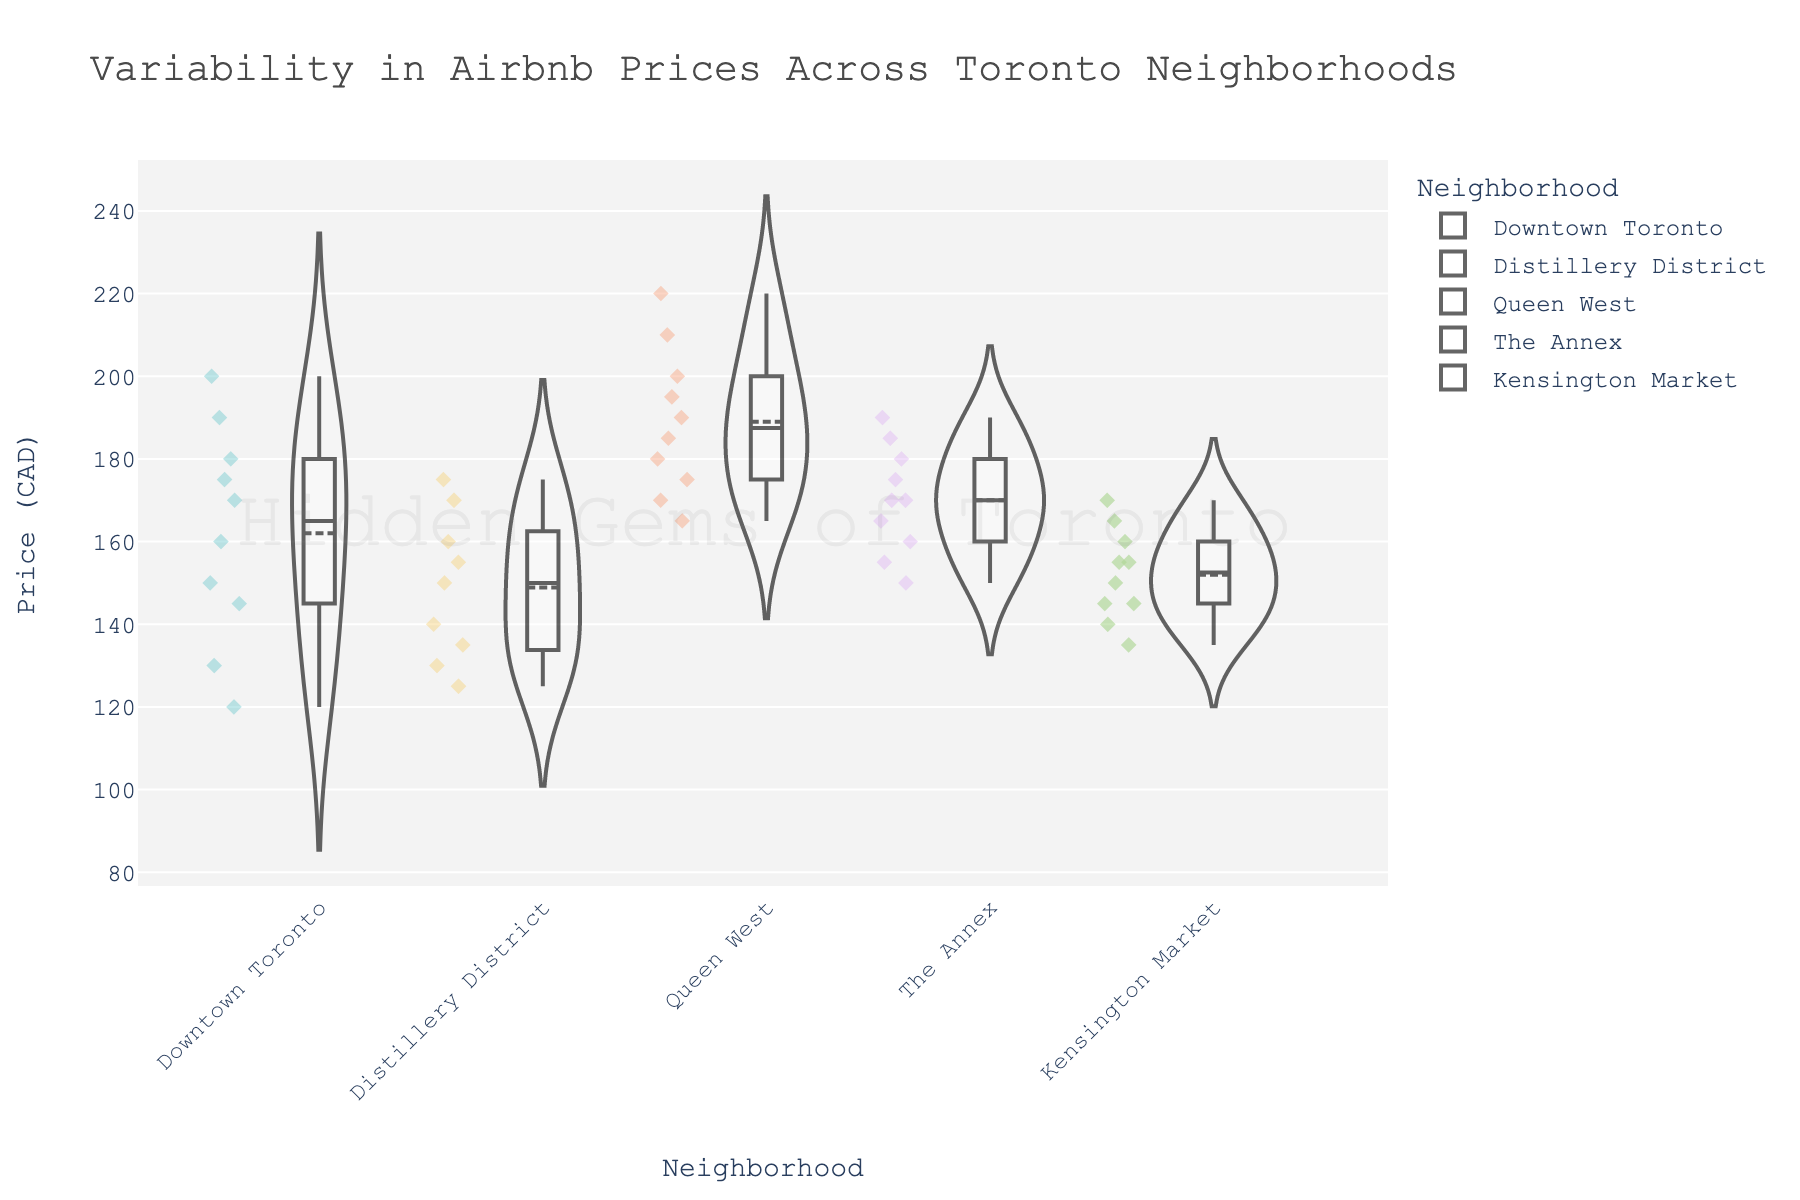what is the title of the violin chart? The title of the violin chart is typically found at the top of the chart. In this case, it is "Variability in Airbnb Prices Across Toronto Neighborhoods" as it is clearly written at the top.
Answer: Variability in Airbnb Prices Across Toronto Neighborhoods which neighborhood shows the widest range of Airbnb prices? By looking at the width of the violin plots, you can see which neighborhood has the widest spread of prices. Queen West has the widest range of prices.
Answer: Queen West what is the median price for Downtown Toronto? The median price is represented by the white line inside the violin plot. For Downtown Toronto, this line is at around 165 CAD.
Answer: 165 CAD Which neighborhood has the highest median price? To identify the highest median price, look at the white line across the central region of each violin plot. Queen West has the highest median price.
Answer: Queen West how many data points are there for Kensington Market? The number of data points is shown by the individual marks within the violin plot. By counting these dots, you can determine that Kensington Market has 10 data points.
Answer: 10 Which neighborhood has the lowest maximum price? To find the lowest maximum price, look at the uppermost part of each violin plot. The Distillery District has the lowest maximum price at around 175 CAD.
Answer: Distillery District what is the average price for listings in The Annex? To calculate the average price, you first need to sum up all the prices and then divide by the total number of listings. Sum prices (160+180+170+165+175+150+155+185+190+170 = 1600) and divide by 10. The average price is 1600/10 = 160 CAD.
Answer: 160 CAD compare the range of prices in Downtown Toronto and Kensington Market. which is larger? The range is the difference between the maximum and minimum prices. Downtown Toronto has a range from 120 to 200 (80 CAD), and Kensington Market has a range from 135 to 170 (35 CAD). Downtown Toronto has a larger range.
Answer: Downtown Toronto what is the interquartile range (IQR) for Queen West? The IQR is the difference between the 75th percentile (upper quartile) and the 25th percentile (lower quartile). In the violin plot, this corresponds to the box in each plot. For Queen West, the IQR is about 190 - 170 = 20 CAD.
Answer: 20 CAD which neighborhood shows a right-skewed distribution? A right-skewed distribution has a longer tail on the right (higher prices). The violin plot for The Annex displays this right-skewed distribution characteristic.
Answer: The Annex 